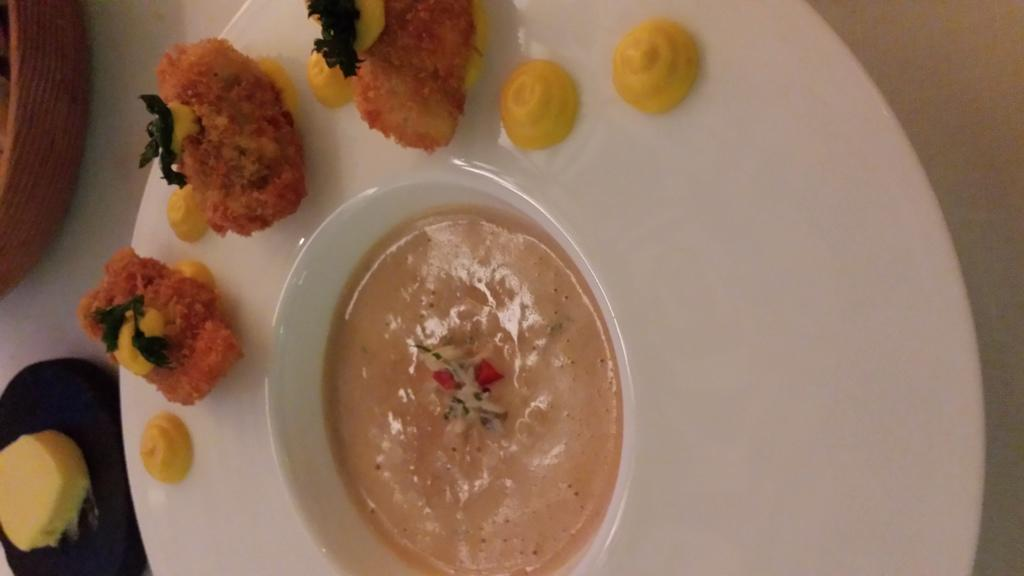What is on the plate that is visible in the image? There is a plate with food items in the image. What else is on the plate besides the bowl? There is a bowl with food items on the plate. Where is the plate located in the image? The plate is on a surface in the image. What is the color of the object near the plate? The object near the plate is black. What is on the black object? Something is on the black object. What type of lace is used to decorate the holiday table in the image? There is no mention of lace or a holiday table in the image; it only shows a plate with food items, a bowl, and a black object. 